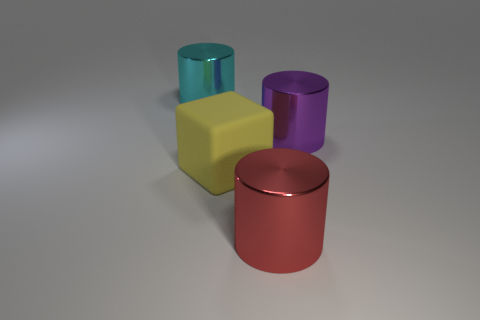Add 1 cubes. How many objects exist? 5 Subtract all cylinders. How many objects are left? 1 Subtract all yellow matte objects. Subtract all red metal cylinders. How many objects are left? 2 Add 3 shiny cylinders. How many shiny cylinders are left? 6 Add 1 large rubber blocks. How many large rubber blocks exist? 2 Subtract 0 green cylinders. How many objects are left? 4 